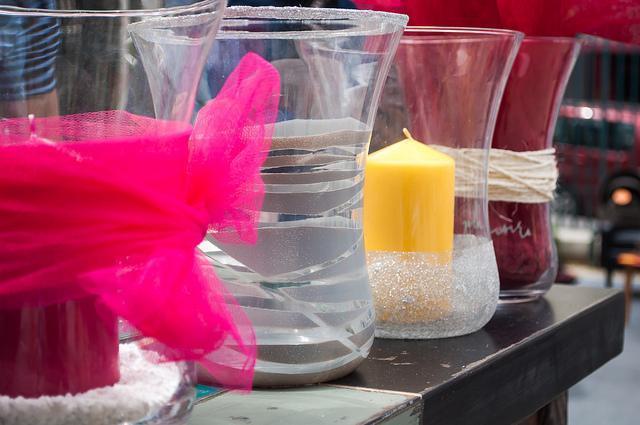How many vases are visible?
Give a very brief answer. 5. 